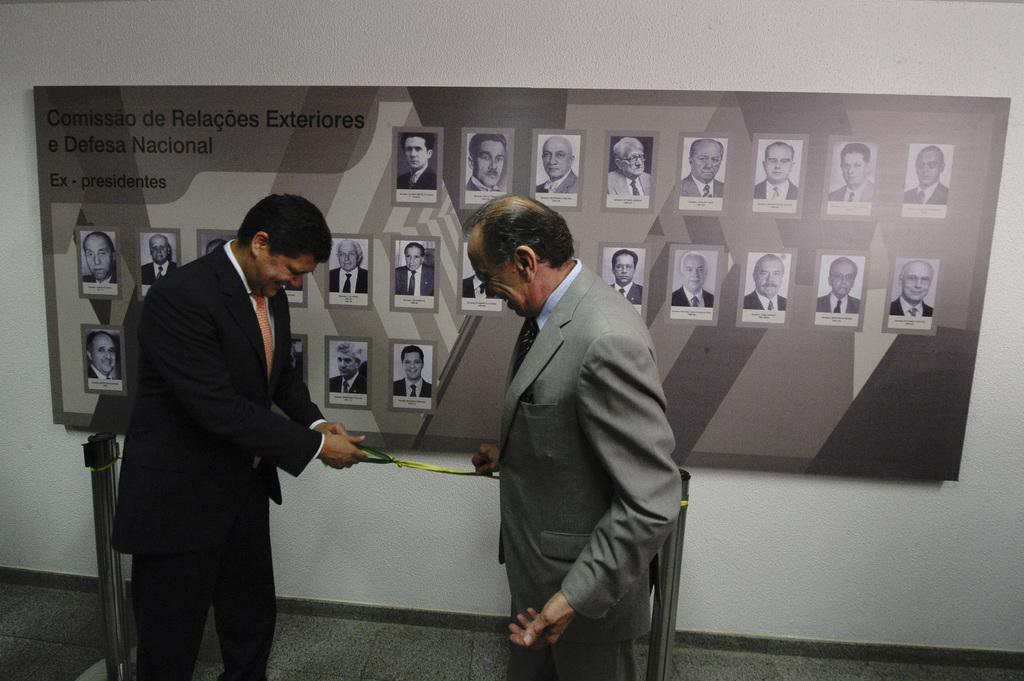How many people are in the image? There are two men in the image. What are the men doing in the image? The men are standing and smiling in the image. What are the men holding in the image? The men are holding a ribbon in the image. What can be seen in the background of the image? There is a banner on the wall in the background of the image. What type of prose is being recited by the men in the image? There is no indication in the image that the men are reciting any prose. What feeling does the organization of the stands in the image convey? There is no mention of an organization in the image, and the stands do not convey any specific feeling. 